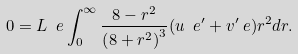<formula> <loc_0><loc_0><loc_500><loc_500>0 = L _ { \ } e \int _ { 0 } ^ { \infty } \frac { 8 - r ^ { 2 } } { \left ( 8 + r ^ { 2 } \right ) ^ { 3 } } ( u _ { \ } e ^ { \prime } + v ^ { \prime } _ { \ } e ) r ^ { 2 } d r .</formula> 